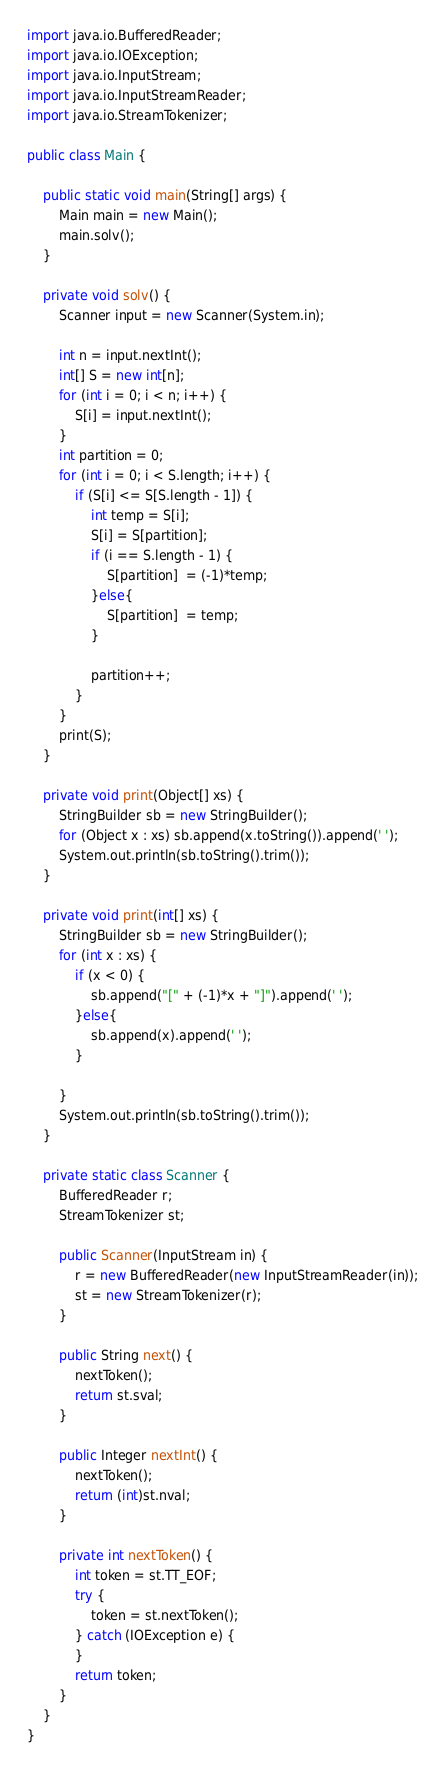Convert code to text. <code><loc_0><loc_0><loc_500><loc_500><_Java_>

import java.io.BufferedReader;
import java.io.IOException;
import java.io.InputStream;
import java.io.InputStreamReader;
import java.io.StreamTokenizer;
 
public class Main {
     
    public static void main(String[] args) {
        Main main = new Main();
        main.solv();
    }
     
    private void solv() {
        Scanner input = new Scanner(System.in);
         
        int n = input.nextInt();
        int[] S = new int[n];
        for (int i = 0; i < n; i++) {
        	S[i] = input.nextInt();
        }
        int partition = 0;
        for (int i = 0; i < S.length; i++) {
			if (S[i] <= S[S.length - 1]) {
				int temp = S[i];
				S[i] = S[partition];
				if (i == S.length - 1) {
					S[partition]  = (-1)*temp;	
				}else{
					S[partition]  = temp;
				}
				
				partition++;
			}
		}
        print(S);
    }
  
    private void print(Object[] xs) {
        StringBuilder sb = new StringBuilder();
        for (Object x : xs) sb.append(x.toString()).append(' ');
        System.out.println(sb.toString().trim());
    }
     
    private void print(int[] xs) {
        StringBuilder sb = new StringBuilder();
        for (int x : xs) {
        	if (x < 0) {
        		sb.append("[" + (-1)*x + "]").append(' ');
			}else{
				sb.append(x).append(' ');	
			}
        	
        }
        System.out.println(sb.toString().trim());
    }
     
    private static class Scanner {
        BufferedReader r;
        StreamTokenizer st;
         
        public Scanner(InputStream in) {
            r = new BufferedReader(new InputStreamReader(in));
            st = new StreamTokenizer(r);
        }
         
        public String next() {
            nextToken();
            return st.sval;
        }
         
        public Integer nextInt() {
            nextToken();
            return (int)st.nval;
        }
         
        private int nextToken() {
            int token = st.TT_EOF;
            try {
                token = st.nextToken();
            } catch (IOException e) {
            }
            return token;
        }
    }
}</code> 